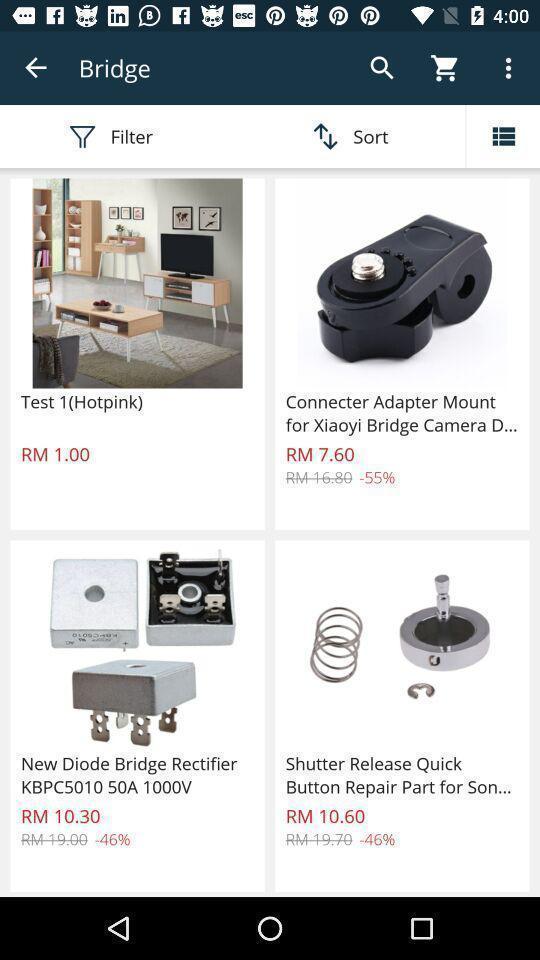What details can you identify in this image? Screen displaying multiple products images with price. 